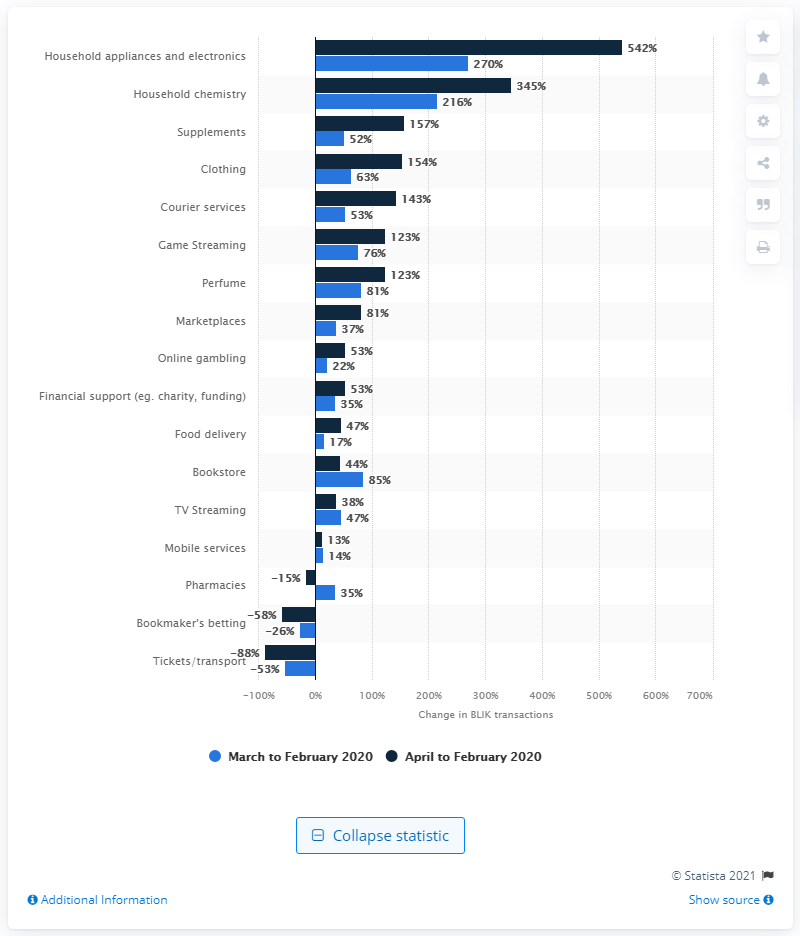Outline some significant characteristics in this image. The number of BLIK transactions in this category increased by 542 compared to February 2020. 